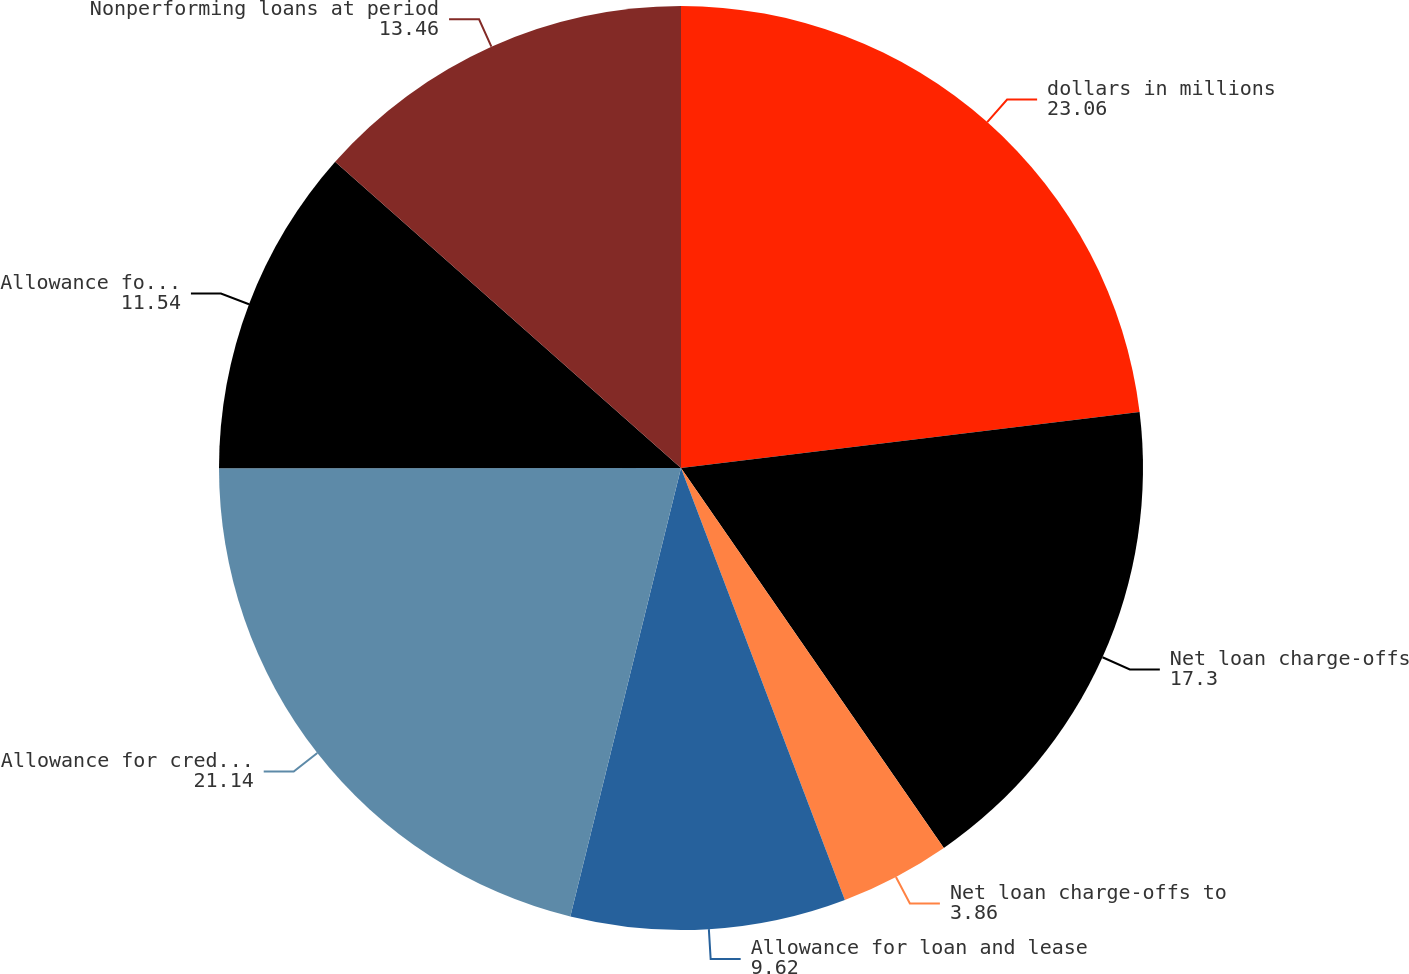Convert chart. <chart><loc_0><loc_0><loc_500><loc_500><pie_chart><fcel>dollars in millions<fcel>Net loan charge-offs<fcel>Net loan charge-offs to<fcel>Allowance for loan and lease<fcel>Allowance for credit losses<fcel>Allowance for credit losses to<fcel>Nonperforming loans at period<nl><fcel>23.06%<fcel>17.3%<fcel>3.86%<fcel>9.62%<fcel>21.14%<fcel>11.54%<fcel>13.46%<nl></chart> 